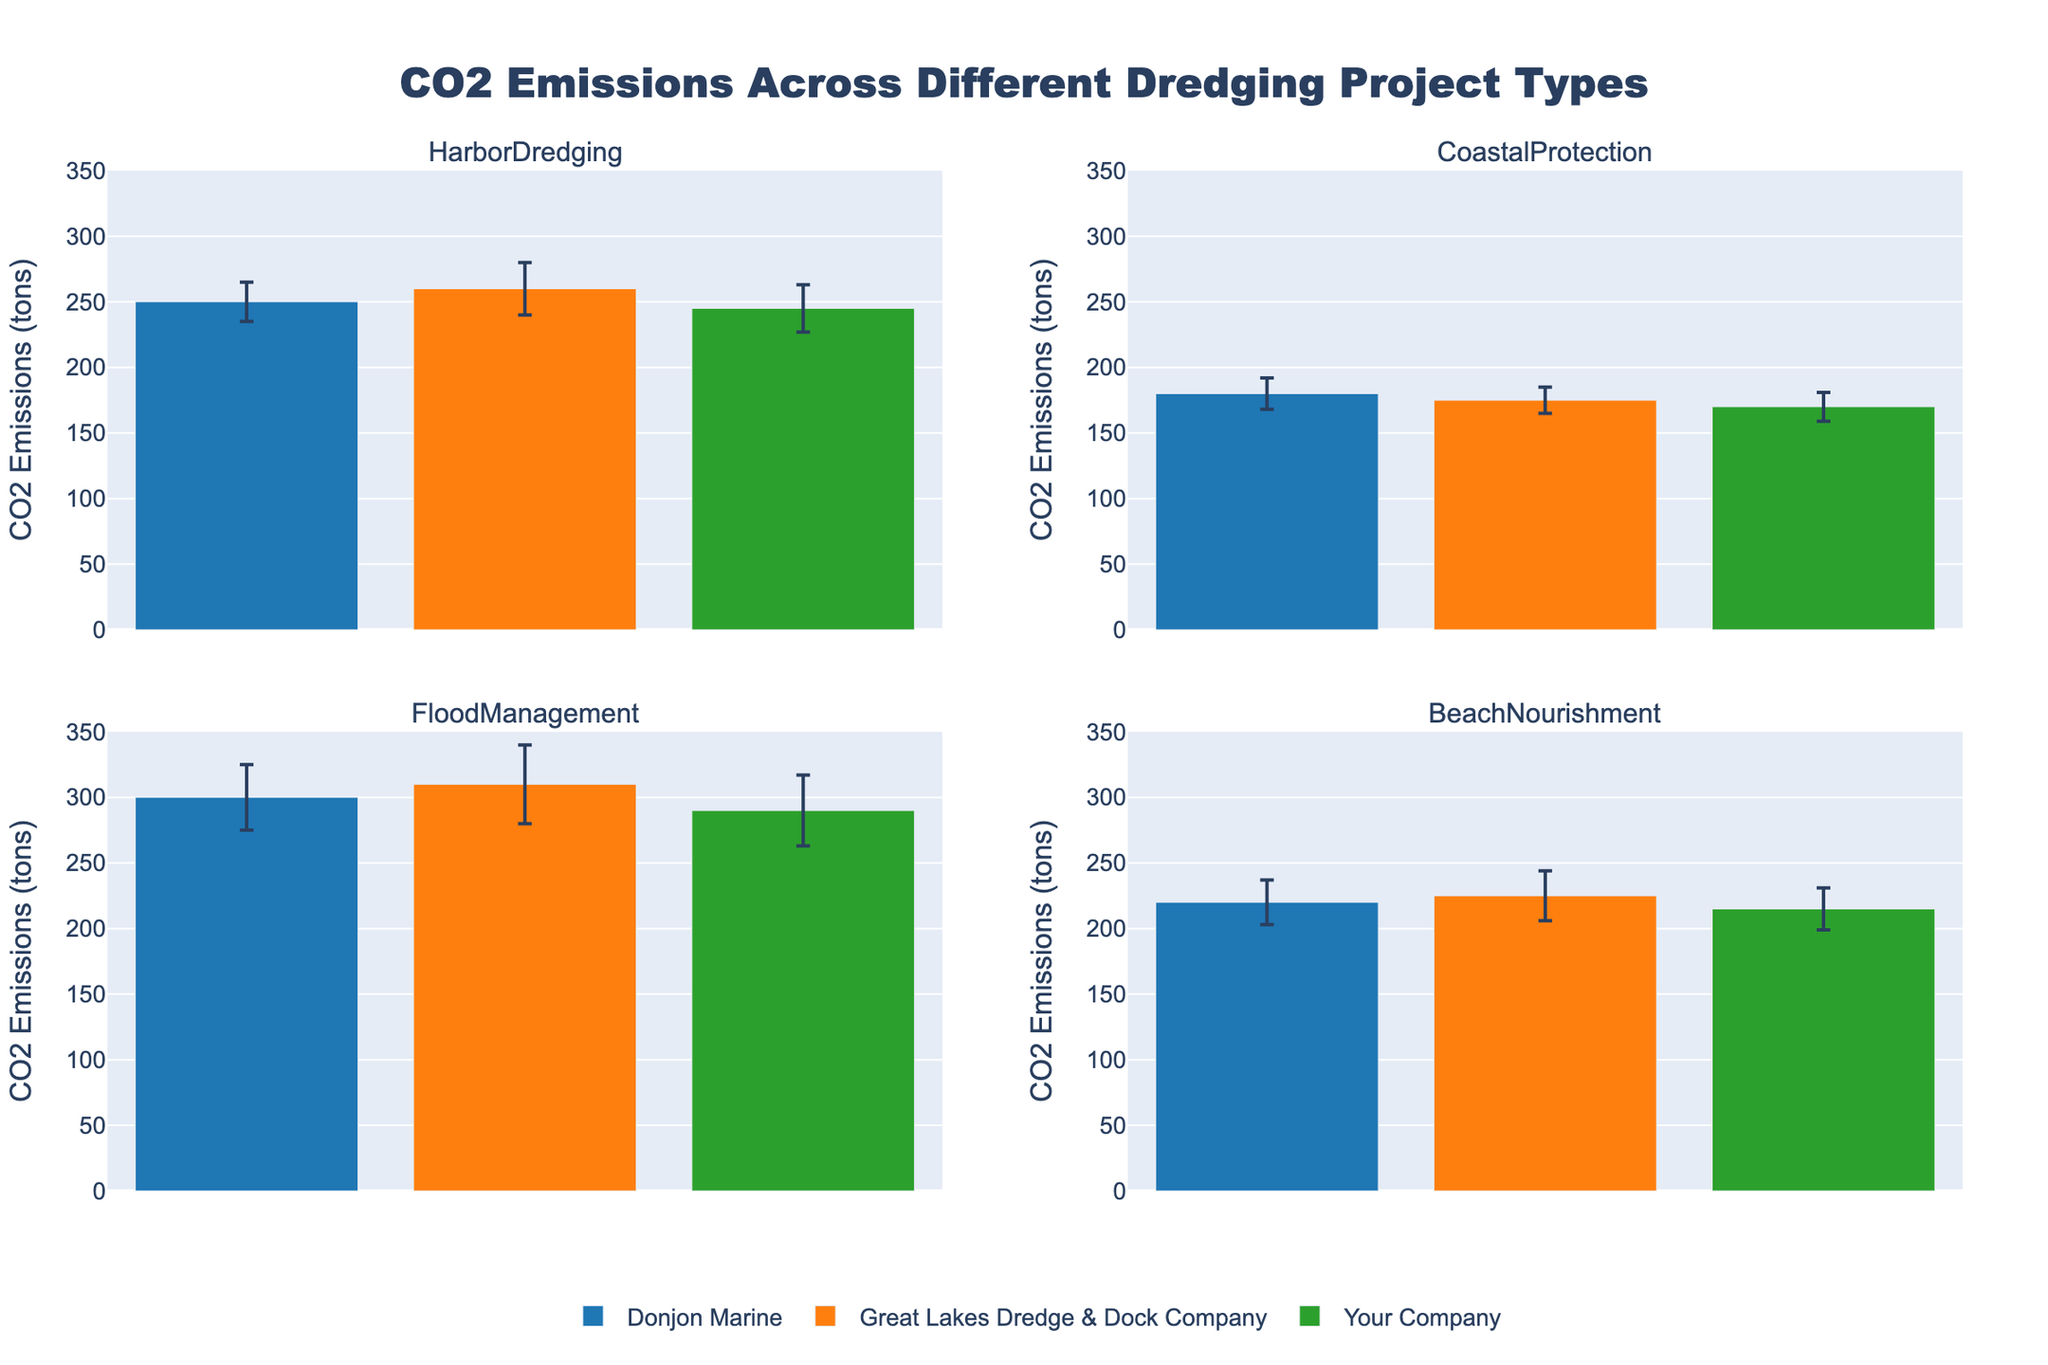What's the title of the figure? The title is displayed at the top center of the figure. It reads 'CO2 Emissions Across Different Dredging Project Types'.
Answer: CO2 Emissions Across Different Dredging Project Types Which company has the highest CO2 emissions for Harbor Dredging? For Harbor Dredging, the figure shows three bars, each representing a company. The tallest bar belongs to Great Lakes Dredge & Dock Company, indicating the highest CO2 emissions.
Answer: Great Lakes Dredge & Dock Company What is the CO2 emission range (mean ± standard deviation) for Your Company in Beach Nourishment? The mean CO2 emission for Your Company in Beach Nourishment is 215 tons and the standard deviation is 16 tons. So, the range is 215 ± 16 tons.
Answer: 199 to 231 tons Among the project types, which has the lowest CO2 emissions for Great Lakes Dredge & Dock Company? The CO2 emissions for Great Lakes Dredge & Dock Company should be compared across all project types. The lowest bar for Great Lakes Dredge & Dock Company is in Coastal Protection with a mean of 175 tons.
Answer: Coastal Protection How do the CO2 emissions of Donjon Marine for Flood Management compare to those of Your Company for the same project type? For Flood Management, Donjon Marine has a CO2 emission mean of 300 tons, while Your Company has a mean of 290 tons. Therefore, Donjon Marine's emissions are higher by 10 tons.
Answer: Donjon Marine's emissions are 10 tons higher What is the average CO2 emission across all project types for Your Company? The CO2 emissions for Your Company across different project types are: Harbor Dredging (245 tons), Coastal Protection (170 tons), Flood Management (290 tons), and Beach Nourishment (215 tons). The average is calculated as (245 + 170 + 290 + 215) / 4.
Answer: 230 tons Which company shows the greatest variability in CO2 emissions for Harbor Dredging? The variability is indicated by the standard deviation represented by the error bars. Great Lakes Dredge & Dock Company has the highest error bar (20 tons) among the companies for Harbor Dredging.
Answer: Great Lakes Dredge & Dock Company What is the total CO2 emission sum for Donjon Marine across all project types? Sum the mean CO2 emissions for Donjon Marine across all project types: 250 (Harbor Dredging) + 180 (Coastal Protection) + 300 (Flood Management) + 220 (Beach Nourishment) = 950 tons.
Answer: 950 tons 